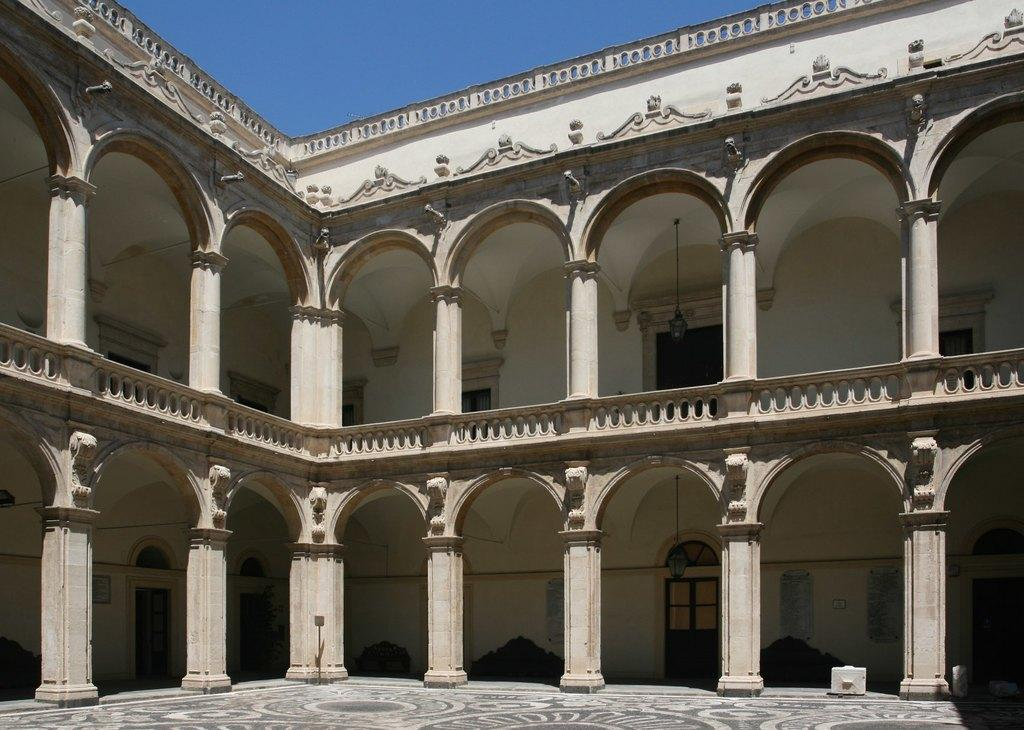What type of structure is visible in the image? There is a building in the image. What can be seen attached to the wall inside the building? There is a board and papers attached to the wall inside the building. What type of illumination is present in the building? There are lights visible in the building. What can be seen in the background of the image? The blue sky is visible in the background of the image. What type of pets are visible in the image? There are no pets visible in the image. What design elements can be seen in the building's interior? The provided facts do not mention any specific design elements in the building's interior. How does the building's acoustics affect the sound quality inside? The provided facts do not mention any information about the building's acoustics. 